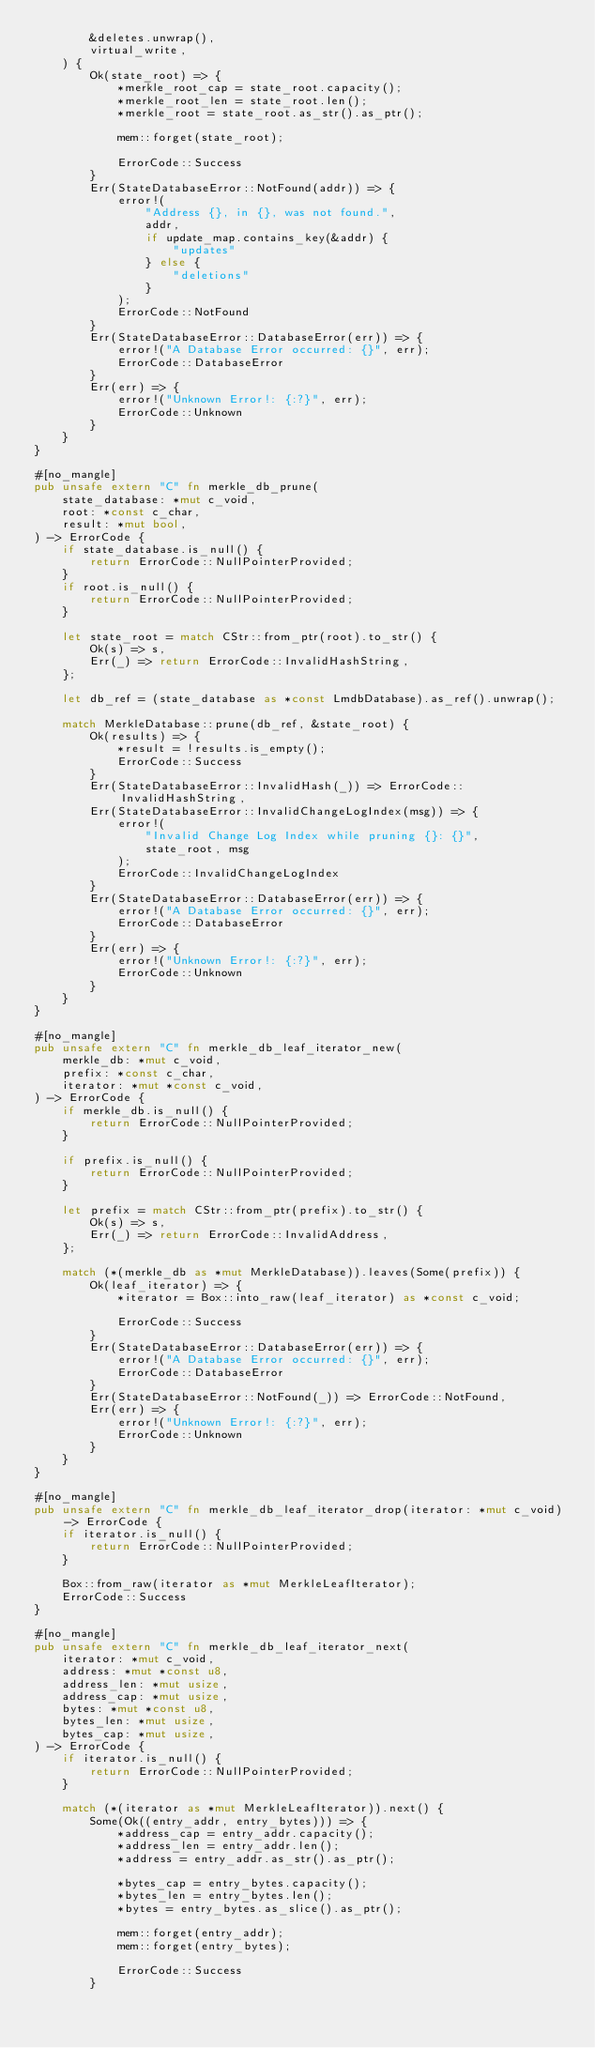<code> <loc_0><loc_0><loc_500><loc_500><_Rust_>        &deletes.unwrap(),
        virtual_write,
    ) {
        Ok(state_root) => {
            *merkle_root_cap = state_root.capacity();
            *merkle_root_len = state_root.len();
            *merkle_root = state_root.as_str().as_ptr();

            mem::forget(state_root);

            ErrorCode::Success
        }
        Err(StateDatabaseError::NotFound(addr)) => {
            error!(
                "Address {}, in {}, was not found.",
                addr,
                if update_map.contains_key(&addr) {
                    "updates"
                } else {
                    "deletions"
                }
            );
            ErrorCode::NotFound
        }
        Err(StateDatabaseError::DatabaseError(err)) => {
            error!("A Database Error occurred: {}", err);
            ErrorCode::DatabaseError
        }
        Err(err) => {
            error!("Unknown Error!: {:?}", err);
            ErrorCode::Unknown
        }
    }
}

#[no_mangle]
pub unsafe extern "C" fn merkle_db_prune(
    state_database: *mut c_void,
    root: *const c_char,
    result: *mut bool,
) -> ErrorCode {
    if state_database.is_null() {
        return ErrorCode::NullPointerProvided;
    }
    if root.is_null() {
        return ErrorCode::NullPointerProvided;
    }

    let state_root = match CStr::from_ptr(root).to_str() {
        Ok(s) => s,
        Err(_) => return ErrorCode::InvalidHashString,
    };

    let db_ref = (state_database as *const LmdbDatabase).as_ref().unwrap();

    match MerkleDatabase::prune(db_ref, &state_root) {
        Ok(results) => {
            *result = !results.is_empty();
            ErrorCode::Success
        }
        Err(StateDatabaseError::InvalidHash(_)) => ErrorCode::InvalidHashString,
        Err(StateDatabaseError::InvalidChangeLogIndex(msg)) => {
            error!(
                "Invalid Change Log Index while pruning {}: {}",
                state_root, msg
            );
            ErrorCode::InvalidChangeLogIndex
        }
        Err(StateDatabaseError::DatabaseError(err)) => {
            error!("A Database Error occurred: {}", err);
            ErrorCode::DatabaseError
        }
        Err(err) => {
            error!("Unknown Error!: {:?}", err);
            ErrorCode::Unknown
        }
    }
}

#[no_mangle]
pub unsafe extern "C" fn merkle_db_leaf_iterator_new(
    merkle_db: *mut c_void,
    prefix: *const c_char,
    iterator: *mut *const c_void,
) -> ErrorCode {
    if merkle_db.is_null() {
        return ErrorCode::NullPointerProvided;
    }

    if prefix.is_null() {
        return ErrorCode::NullPointerProvided;
    }

    let prefix = match CStr::from_ptr(prefix).to_str() {
        Ok(s) => s,
        Err(_) => return ErrorCode::InvalidAddress,
    };

    match (*(merkle_db as *mut MerkleDatabase)).leaves(Some(prefix)) {
        Ok(leaf_iterator) => {
            *iterator = Box::into_raw(leaf_iterator) as *const c_void;

            ErrorCode::Success
        }
        Err(StateDatabaseError::DatabaseError(err)) => {
            error!("A Database Error occurred: {}", err);
            ErrorCode::DatabaseError
        }
        Err(StateDatabaseError::NotFound(_)) => ErrorCode::NotFound,
        Err(err) => {
            error!("Unknown Error!: {:?}", err);
            ErrorCode::Unknown
        }
    }
}

#[no_mangle]
pub unsafe extern "C" fn merkle_db_leaf_iterator_drop(iterator: *mut c_void) -> ErrorCode {
    if iterator.is_null() {
        return ErrorCode::NullPointerProvided;
    }

    Box::from_raw(iterator as *mut MerkleLeafIterator);
    ErrorCode::Success
}

#[no_mangle]
pub unsafe extern "C" fn merkle_db_leaf_iterator_next(
    iterator: *mut c_void,
    address: *mut *const u8,
    address_len: *mut usize,
    address_cap: *mut usize,
    bytes: *mut *const u8,
    bytes_len: *mut usize,
    bytes_cap: *mut usize,
) -> ErrorCode {
    if iterator.is_null() {
        return ErrorCode::NullPointerProvided;
    }

    match (*(iterator as *mut MerkleLeafIterator)).next() {
        Some(Ok((entry_addr, entry_bytes))) => {
            *address_cap = entry_addr.capacity();
            *address_len = entry_addr.len();
            *address = entry_addr.as_str().as_ptr();

            *bytes_cap = entry_bytes.capacity();
            *bytes_len = entry_bytes.len();
            *bytes = entry_bytes.as_slice().as_ptr();

            mem::forget(entry_addr);
            mem::forget(entry_bytes);

            ErrorCode::Success
        }</code> 